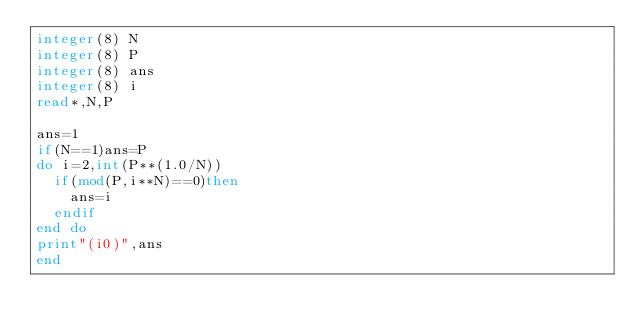<code> <loc_0><loc_0><loc_500><loc_500><_FORTRAN_>integer(8) N
integer(8) P
integer(8) ans
integer(8) i
read*,N,P

ans=1
if(N==1)ans=P
do i=2,int(P**(1.0/N))
  if(mod(P,i**N)==0)then
    ans=i
  endif
end do
print"(i0)",ans
end</code> 